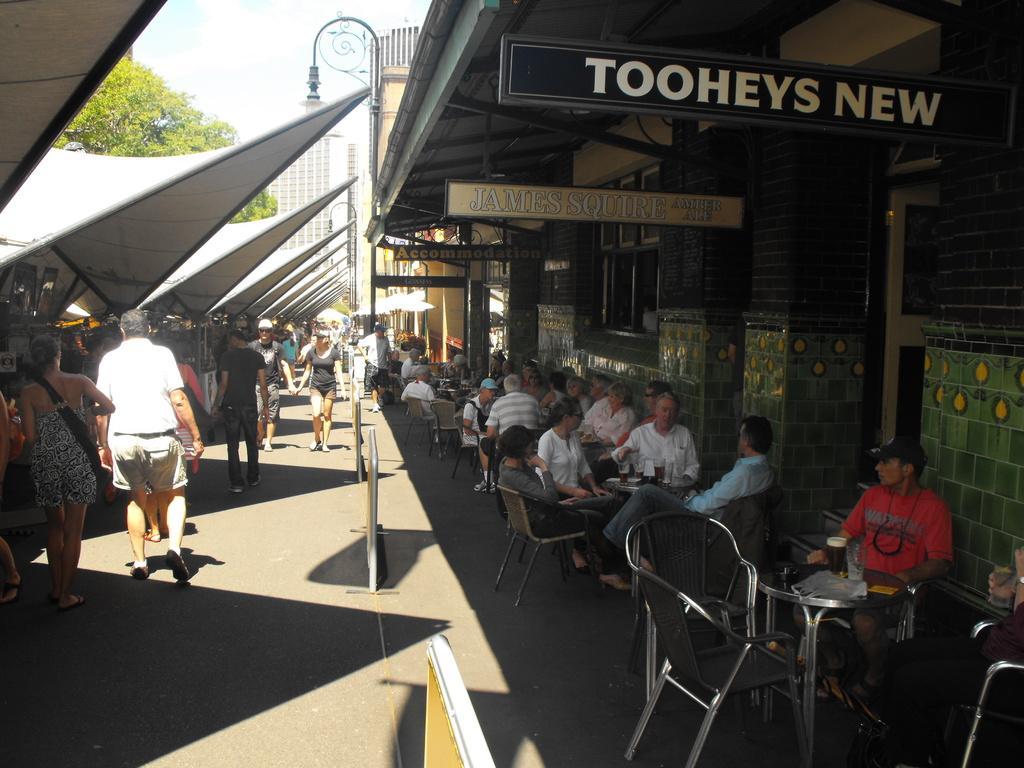Could you give a brief overview of what you see in this image? In the foreground I can see a crow is sitting in the chairs in front of the table on which I can see bottles, glasses and so on. In the left I can see a crowd is walking on the road and tents. In the background I can see shops, street lights, buildings and trees. On the top I can see the sky. This image is taken during a day. 